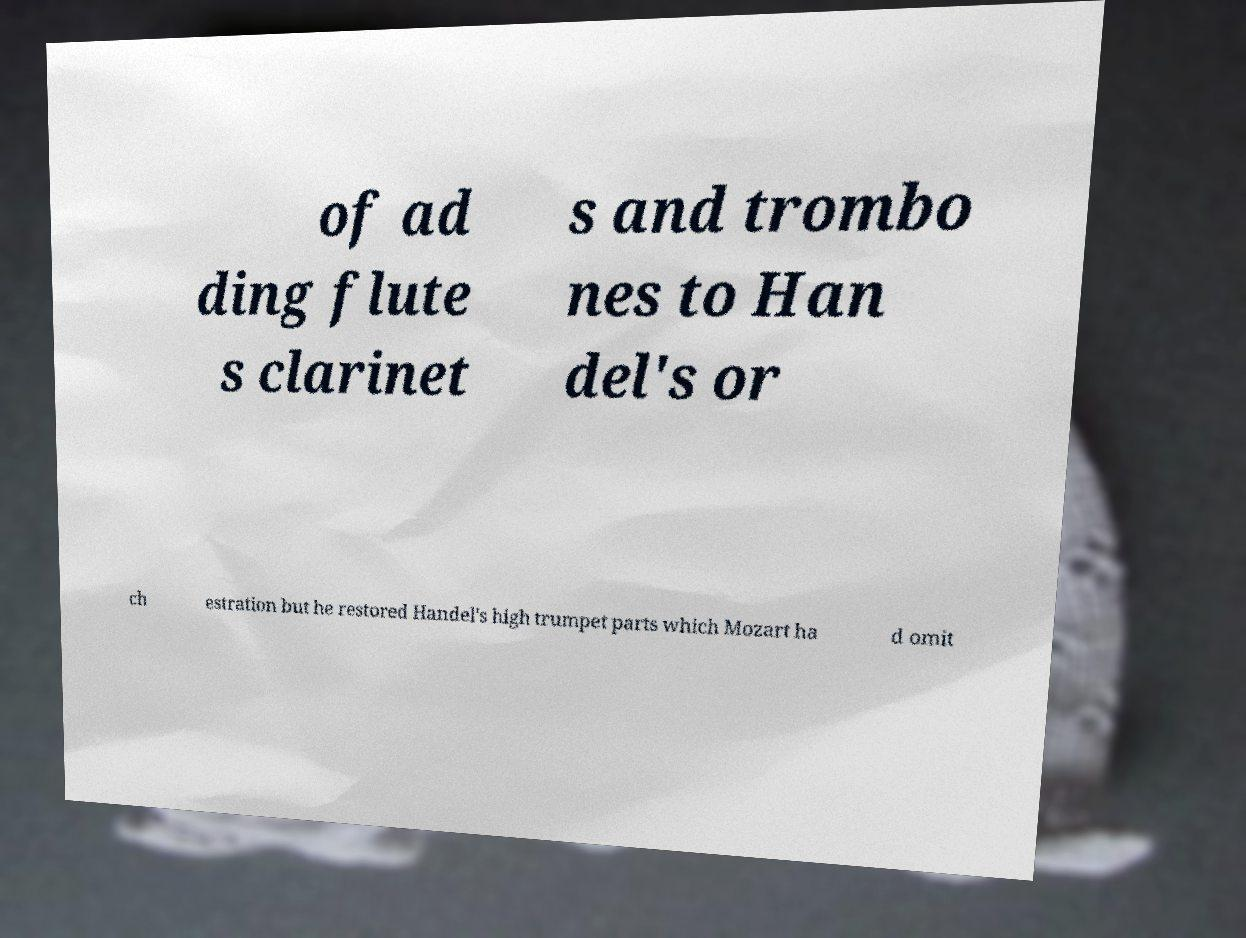Can you read and provide the text displayed in the image?This photo seems to have some interesting text. Can you extract and type it out for me? of ad ding flute s clarinet s and trombo nes to Han del's or ch estration but he restored Handel's high trumpet parts which Mozart ha d omit 